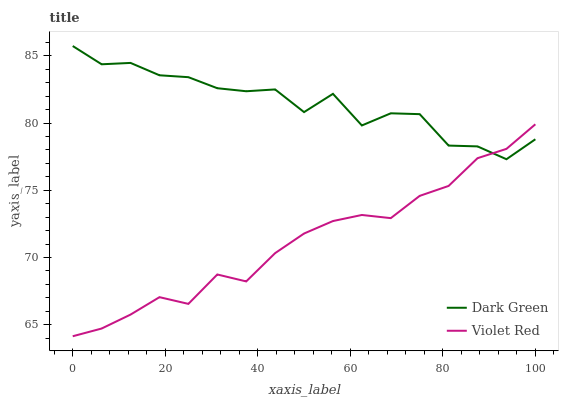Does Violet Red have the minimum area under the curve?
Answer yes or no. Yes. Does Dark Green have the maximum area under the curve?
Answer yes or no. Yes. Does Dark Green have the minimum area under the curve?
Answer yes or no. No. Is Violet Red the smoothest?
Answer yes or no. Yes. Is Dark Green the roughest?
Answer yes or no. Yes. Is Dark Green the smoothest?
Answer yes or no. No. Does Violet Red have the lowest value?
Answer yes or no. Yes. Does Dark Green have the lowest value?
Answer yes or no. No. Does Dark Green have the highest value?
Answer yes or no. Yes. Does Violet Red intersect Dark Green?
Answer yes or no. Yes. Is Violet Red less than Dark Green?
Answer yes or no. No. Is Violet Red greater than Dark Green?
Answer yes or no. No. 